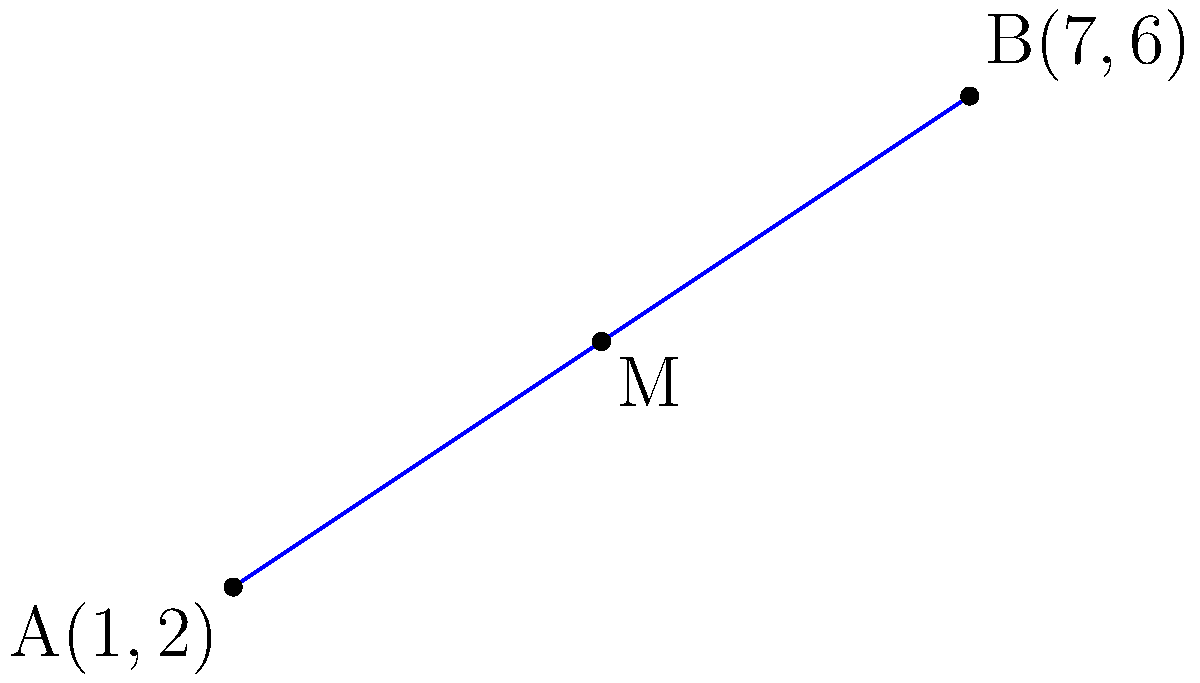As someone who loves to share useful resources, you've come across a helpful method for finding the midpoint of a line segment. Given the coordinates of two points A(1,2) and B(7,6), determine the coordinates of the midpoint M of line segment AB. How would you explain this process to others who might find it useful? To find the midpoint of a line segment, we can follow these steps:

1. Identify the coordinates of the two endpoints:
   Point A: $(x_1, y_1) = (1, 2)$
   Point B: $(x_2, y_2) = (7, 6)$

2. Use the midpoint formula:
   The midpoint formula states that the coordinates of the midpoint M$(x_m, y_m)$ are:
   
   $x_m = \frac{x_1 + x_2}{2}$ and $y_m = \frac{y_1 + y_2}{2}$

3. Calculate the x-coordinate of the midpoint:
   $x_m = \frac{x_1 + x_2}{2} = \frac{1 + 7}{2} = \frac{8}{2} = 4$

4. Calculate the y-coordinate of the midpoint:
   $y_m = \frac{y_1 + y_2}{2} = \frac{2 + 6}{2} = \frac{8}{2} = 4$

5. Combine the results:
   The midpoint M has coordinates $(x_m, y_m) = (4, 4)$

This method is a useful resource for quickly finding the midpoint of any line segment when given the coordinates of its endpoints.
Answer: $(4, 4)$ 